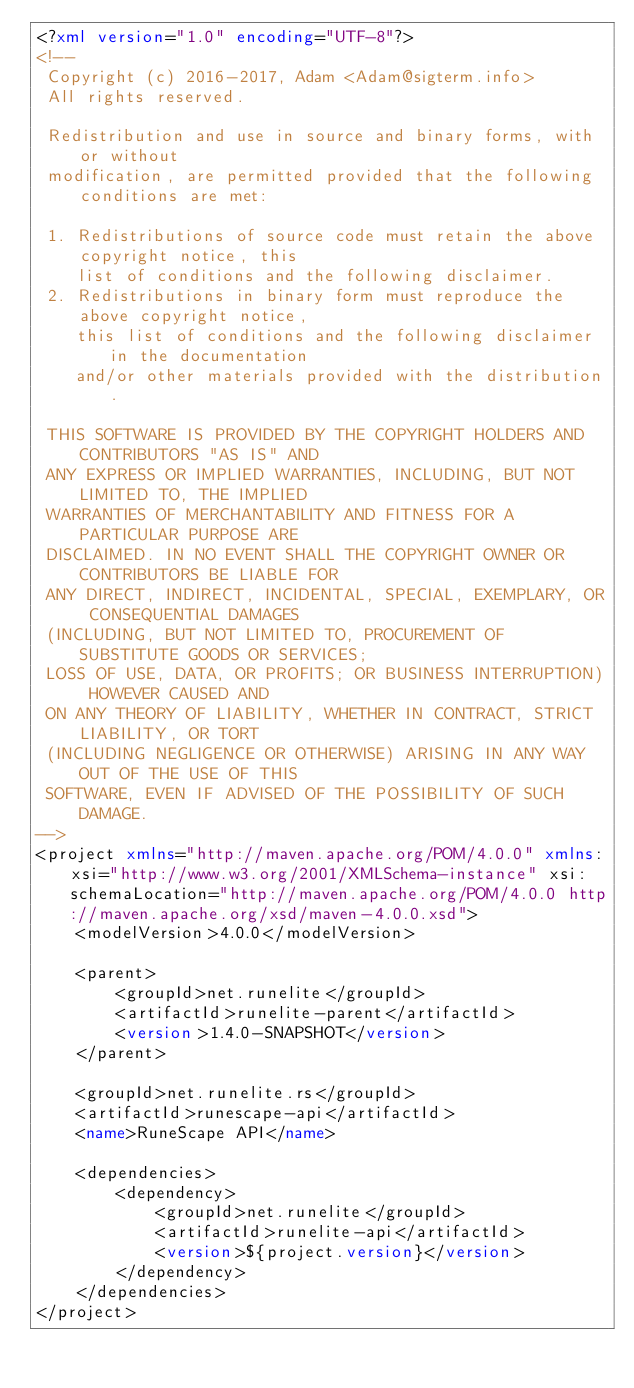Convert code to text. <code><loc_0><loc_0><loc_500><loc_500><_XML_><?xml version="1.0" encoding="UTF-8"?>
<!--
 Copyright (c) 2016-2017, Adam <Adam@sigterm.info>
 All rights reserved.

 Redistribution and use in source and binary forms, with or without
 modification, are permitted provided that the following conditions are met:

 1. Redistributions of source code must retain the above copyright notice, this
    list of conditions and the following disclaimer.
 2. Redistributions in binary form must reproduce the above copyright notice,
    this list of conditions and the following disclaimer in the documentation
    and/or other materials provided with the distribution.

 THIS SOFTWARE IS PROVIDED BY THE COPYRIGHT HOLDERS AND CONTRIBUTORS "AS IS" AND
 ANY EXPRESS OR IMPLIED WARRANTIES, INCLUDING, BUT NOT LIMITED TO, THE IMPLIED
 WARRANTIES OF MERCHANTABILITY AND FITNESS FOR A PARTICULAR PURPOSE ARE
 DISCLAIMED. IN NO EVENT SHALL THE COPYRIGHT OWNER OR CONTRIBUTORS BE LIABLE FOR
 ANY DIRECT, INDIRECT, INCIDENTAL, SPECIAL, EXEMPLARY, OR CONSEQUENTIAL DAMAGES
 (INCLUDING, BUT NOT LIMITED TO, PROCUREMENT OF SUBSTITUTE GOODS OR SERVICES;
 LOSS OF USE, DATA, OR PROFITS; OR BUSINESS INTERRUPTION) HOWEVER CAUSED AND
 ON ANY THEORY OF LIABILITY, WHETHER IN CONTRACT, STRICT LIABILITY, OR TORT
 (INCLUDING NEGLIGENCE OR OTHERWISE) ARISING IN ANY WAY OUT OF THE USE OF THIS
 SOFTWARE, EVEN IF ADVISED OF THE POSSIBILITY OF SUCH DAMAGE.
-->
<project xmlns="http://maven.apache.org/POM/4.0.0" xmlns:xsi="http://www.w3.org/2001/XMLSchema-instance" xsi:schemaLocation="http://maven.apache.org/POM/4.0.0 http://maven.apache.org/xsd/maven-4.0.0.xsd">
	<modelVersion>4.0.0</modelVersion>

	<parent>
		<groupId>net.runelite</groupId>
		<artifactId>runelite-parent</artifactId>
		<version>1.4.0-SNAPSHOT</version>
	</parent>

	<groupId>net.runelite.rs</groupId>
	<artifactId>runescape-api</artifactId>
	<name>RuneScape API</name>

	<dependencies>
		<dependency>
			<groupId>net.runelite</groupId>
			<artifactId>runelite-api</artifactId>
			<version>${project.version}</version>
		</dependency>
	</dependencies>
</project>
</code> 